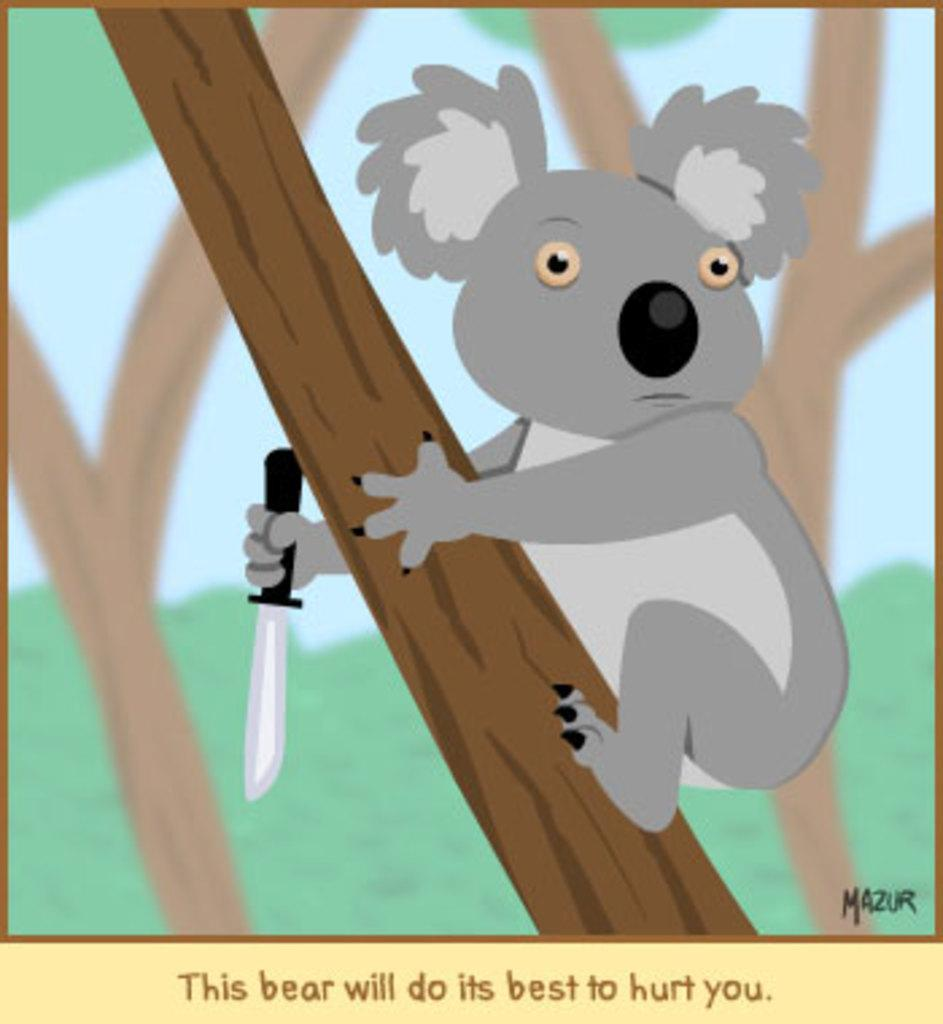What type of image is depicted in the picture? There is a cartoon image in the picture. What natural elements can be seen in the image? There are trunks of trees in the image. What is the animal in the image doing? The animal is holding a knife in the image. What type of skirt is the animal wearing in the image? There is no skirt present in the image; the animal is holding a knife. What type of lace can be seen on the cartoon image? There is no lace present in the image; it is a cartoon image with trees and an animal holding a knife. 